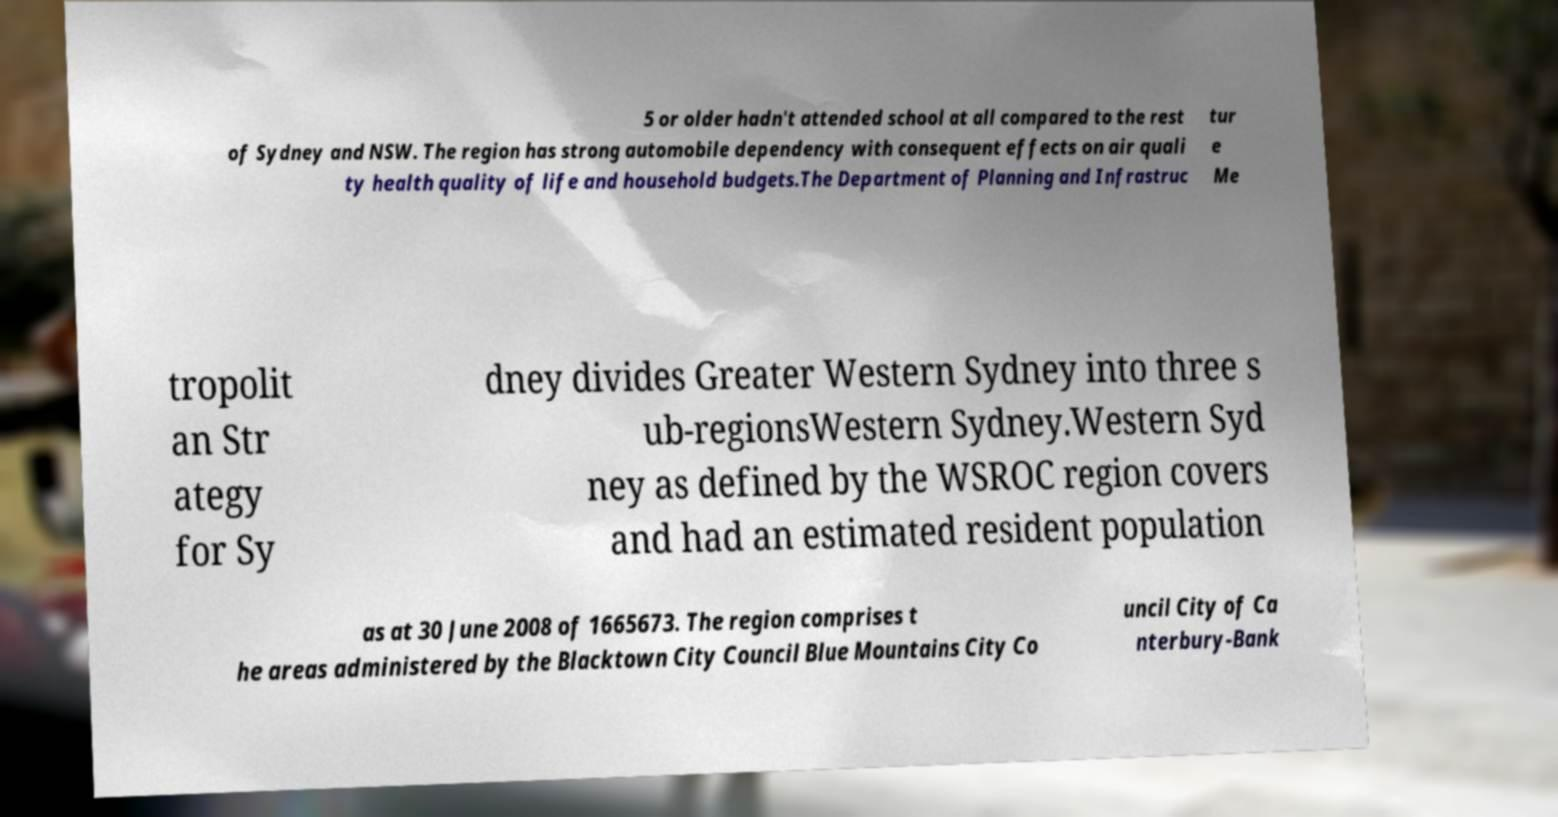Can you read and provide the text displayed in the image?This photo seems to have some interesting text. Can you extract and type it out for me? 5 or older hadn't attended school at all compared to the rest of Sydney and NSW. The region has strong automobile dependency with consequent effects on air quali ty health quality of life and household budgets.The Department of Planning and Infrastruc tur e Me tropolit an Str ategy for Sy dney divides Greater Western Sydney into three s ub-regionsWestern Sydney.Western Syd ney as defined by the WSROC region covers and had an estimated resident population as at 30 June 2008 of 1665673. The region comprises t he areas administered by the Blacktown City Council Blue Mountains City Co uncil City of Ca nterbury-Bank 